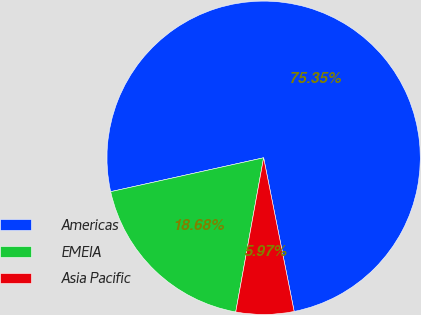Convert chart to OTSL. <chart><loc_0><loc_0><loc_500><loc_500><pie_chart><fcel>Americas<fcel>EMEIA<fcel>Asia Pacific<nl><fcel>75.35%<fcel>18.68%<fcel>5.97%<nl></chart> 